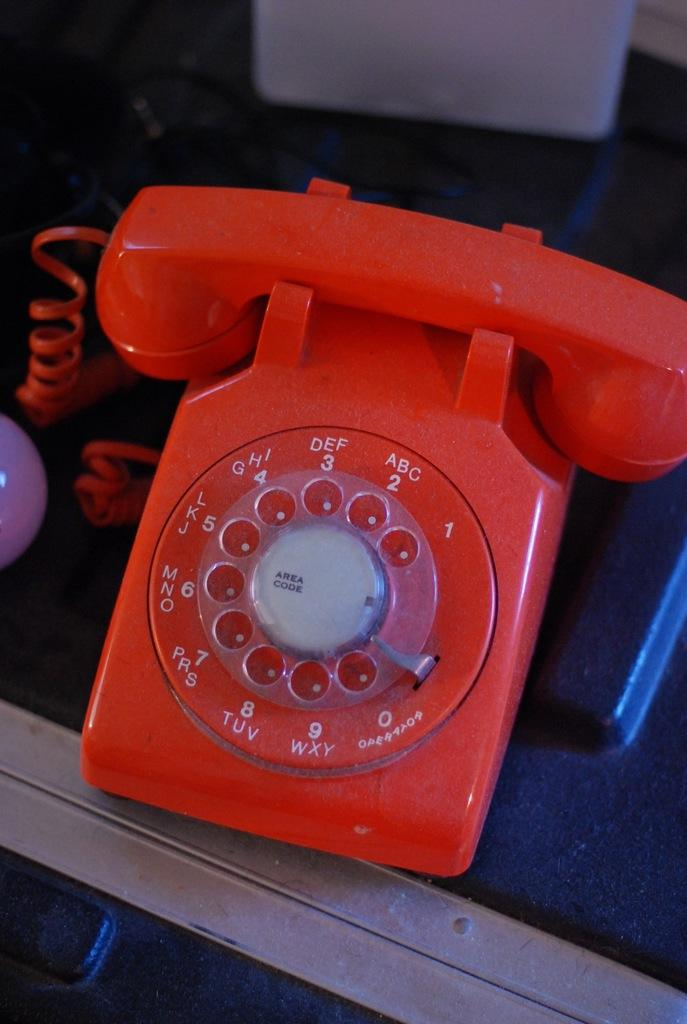<image>
Describe the image concisely. An orange dial phone features an Operator label on the zero number. 